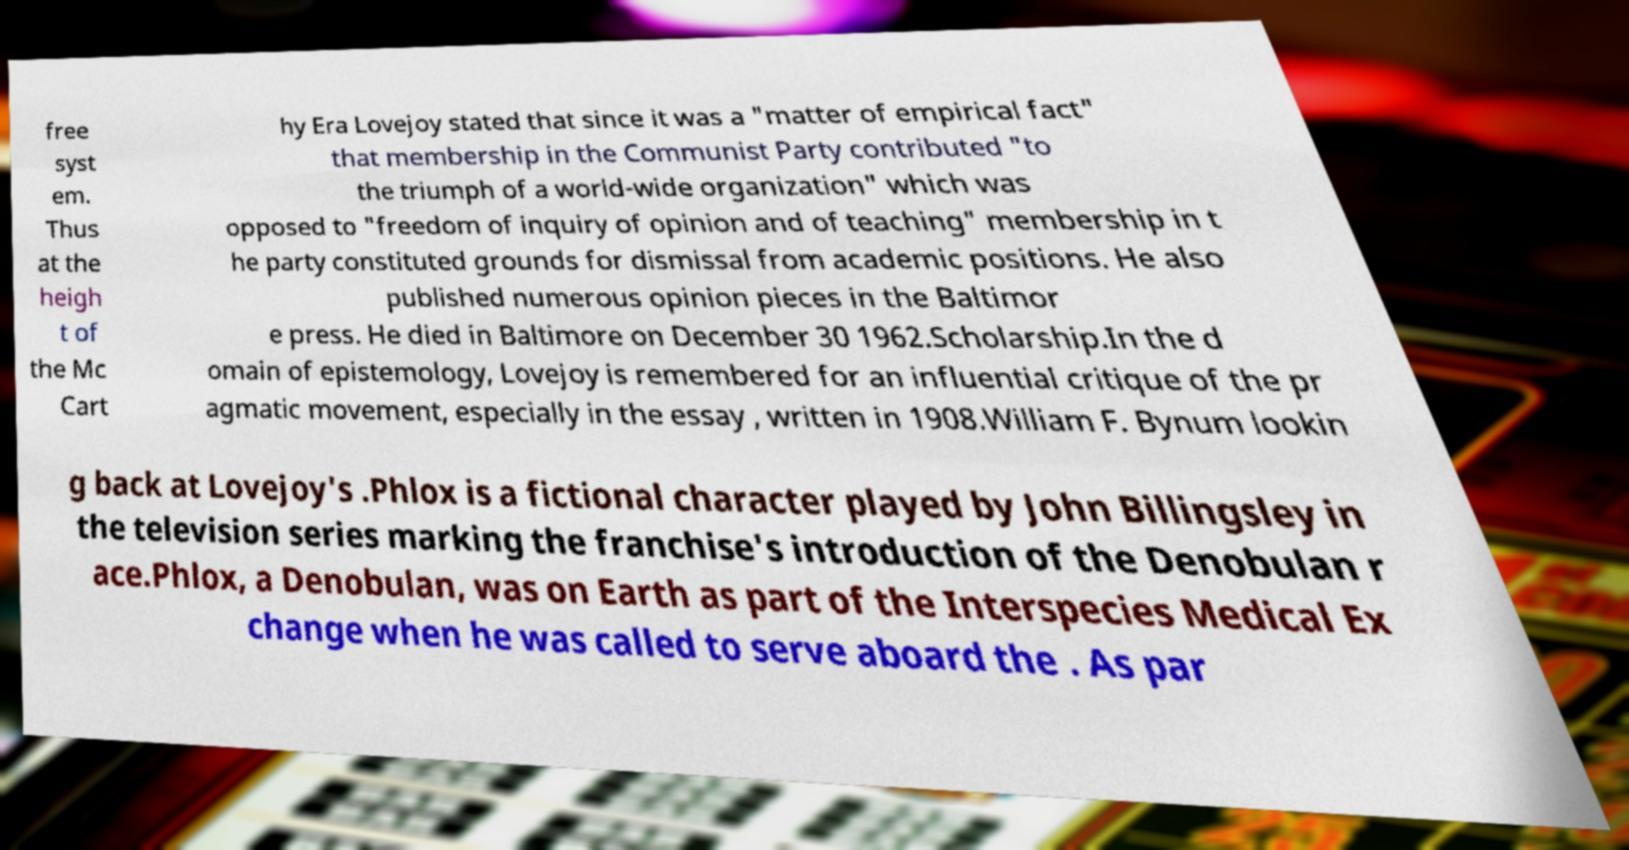Can you read and provide the text displayed in the image?This photo seems to have some interesting text. Can you extract and type it out for me? free syst em. Thus at the heigh t of the Mc Cart hy Era Lovejoy stated that since it was a "matter of empirical fact" that membership in the Communist Party contributed "to the triumph of a world-wide organization" which was opposed to "freedom of inquiry of opinion and of teaching" membership in t he party constituted grounds for dismissal from academic positions. He also published numerous opinion pieces in the Baltimor e press. He died in Baltimore on December 30 1962.Scholarship.In the d omain of epistemology, Lovejoy is remembered for an influential critique of the pr agmatic movement, especially in the essay , written in 1908.William F. Bynum lookin g back at Lovejoy's .Phlox is a fictional character played by John Billingsley in the television series marking the franchise's introduction of the Denobulan r ace.Phlox, a Denobulan, was on Earth as part of the Interspecies Medical Ex change when he was called to serve aboard the . As par 